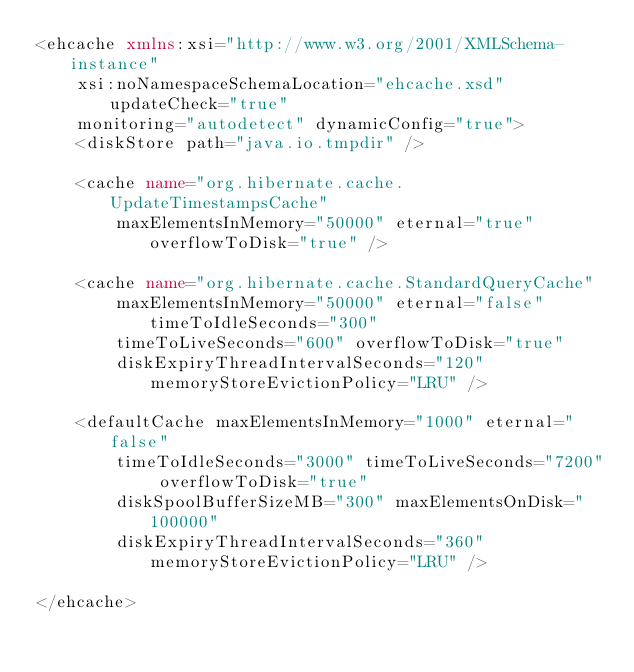<code> <loc_0><loc_0><loc_500><loc_500><_XML_><ehcache xmlns:xsi="http://www.w3.org/2001/XMLSchema-instance"
	xsi:noNamespaceSchemaLocation="ehcache.xsd" updateCheck="true"
	monitoring="autodetect" dynamicConfig="true">
	<diskStore path="java.io.tmpdir" />

	<cache name="org.hibernate.cache.UpdateTimestampsCache"
		maxElementsInMemory="50000" eternal="true" overflowToDisk="true" />

	<cache name="org.hibernate.cache.StandardQueryCache"
		maxElementsInMemory="50000" eternal="false" timeToIdleSeconds="300"
		timeToLiveSeconds="600" overflowToDisk="true"
		diskExpiryThreadIntervalSeconds="120" memoryStoreEvictionPolicy="LRU" />

	<defaultCache maxElementsInMemory="1000" eternal="false"
		timeToIdleSeconds="3000" timeToLiveSeconds="7200" overflowToDisk="true"
		diskSpoolBufferSizeMB="300" maxElementsOnDisk="100000"
		diskExpiryThreadIntervalSeconds="360" memoryStoreEvictionPolicy="LRU" />

</ehcache></code> 